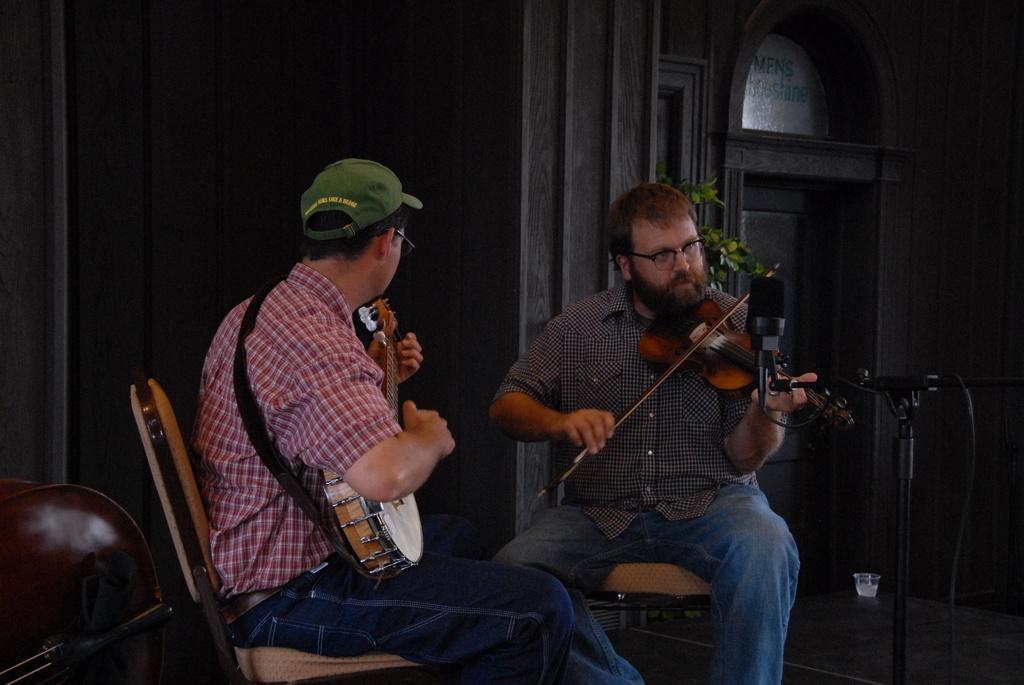In one or two sentences, can you explain what this image depicts? In this picture,There are some chairs which are in brown color, There are some people sitting on the chairs and they are holding some music instruments, In the right side there is a microphone which is in black color, In the background there are some black color walls. 